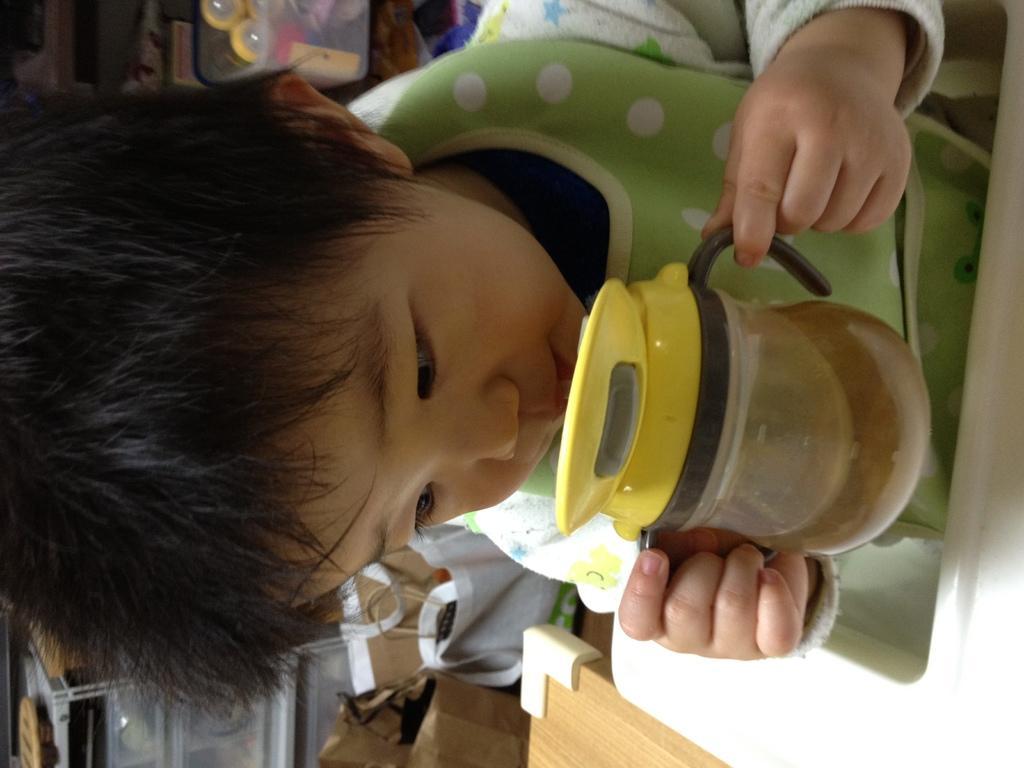Describe this image in one or two sentences. In this image we can see a kid drinking some drink, he is holding a bottle, there is a table, behind him, there are packages, there are some objects in a box. 